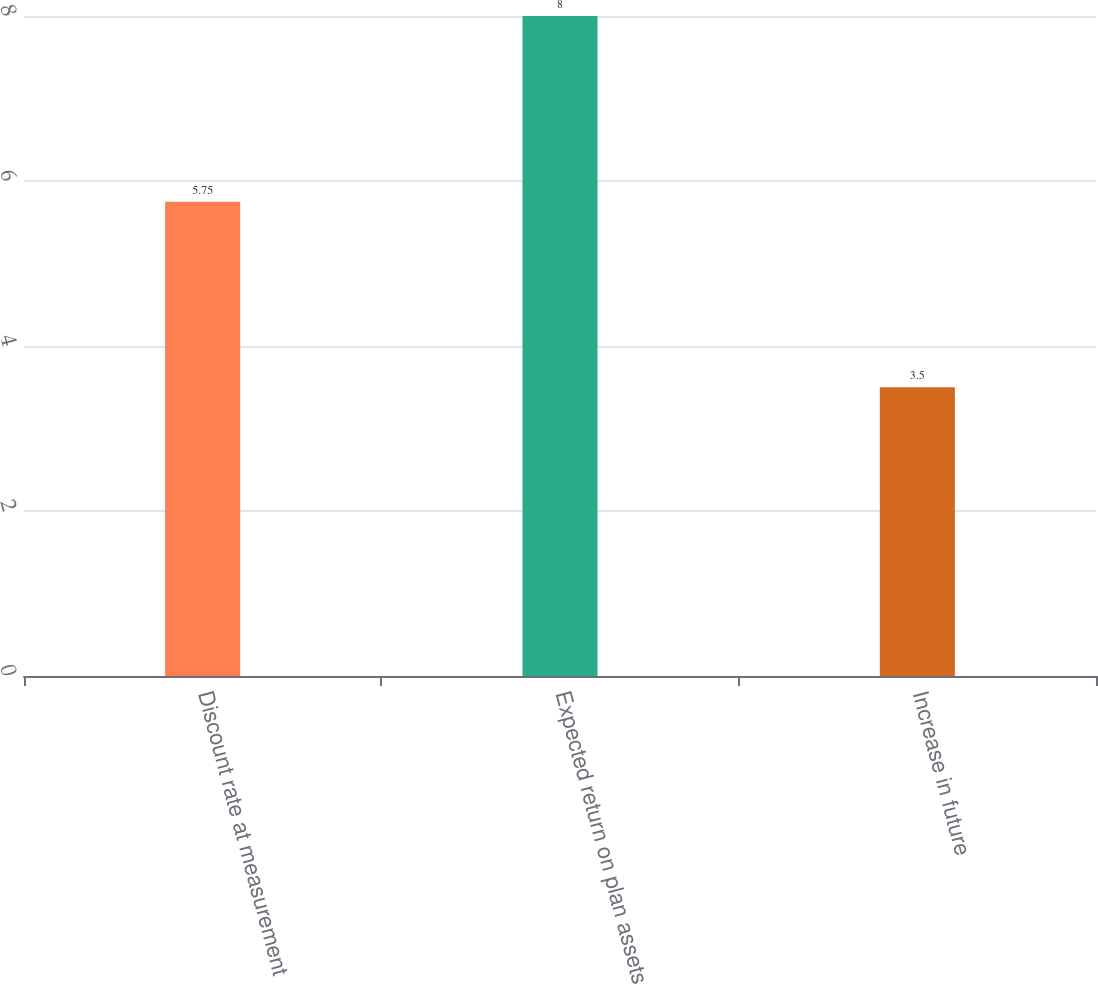Convert chart to OTSL. <chart><loc_0><loc_0><loc_500><loc_500><bar_chart><fcel>Discount rate at measurement<fcel>Expected return on plan assets<fcel>Increase in future<nl><fcel>5.75<fcel>8<fcel>3.5<nl></chart> 